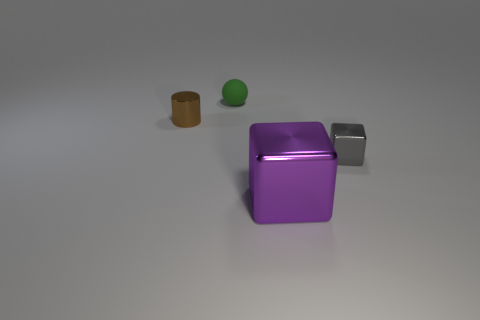Is the material of the thing that is on the left side of the green matte object the same as the ball?
Offer a terse response. No. Are there any other things that have the same material as the small ball?
Provide a succinct answer. No. The purple object that is the same material as the tiny brown cylinder is what size?
Your answer should be compact. Large. Do the green rubber object and the purple block have the same size?
Provide a short and direct response. No. Is the shape of the big purple metal object the same as the gray metallic object?
Provide a short and direct response. Yes. What color is the block that is made of the same material as the purple thing?
Keep it short and to the point. Gray. What number of objects are things behind the small gray metallic thing or large metal objects?
Your response must be concise. 3. There is a shiny block that is on the left side of the gray thing; what size is it?
Offer a very short reply. Large. There is a metallic cylinder; is its size the same as the purple cube right of the metallic cylinder?
Your answer should be very brief. No. What is the color of the tiny object right of the shiny block in front of the gray metal cube?
Provide a short and direct response. Gray. 